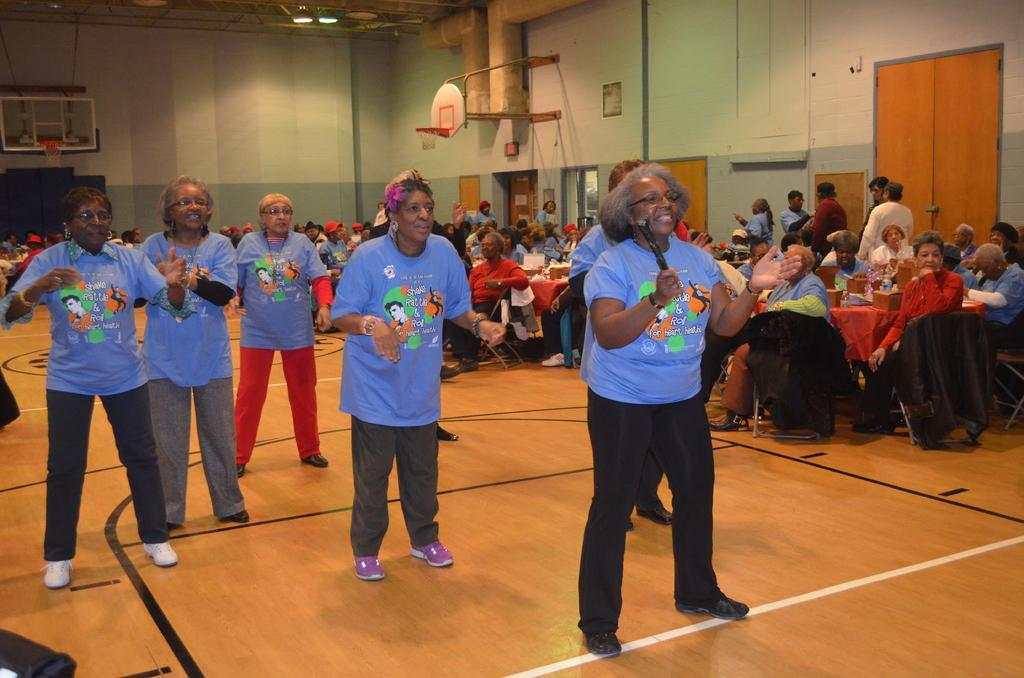Who is the main subject of the image? The main subjects of the image are the old people. What are the old people doing in the image? The old people are dancing in the middle of a room. Are there any other people in the image? Yes, there are other people in the image. What are the other people doing? The other people are sitting and standing around tables, watching the old people dance. How many balloons are tied to the chin of the old man in the image? There are no balloons or chins mentioned in the image; it only describes old people dancing and other people watching them. 